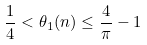<formula> <loc_0><loc_0><loc_500><loc_500>\frac { 1 } { 4 } < \theta _ { 1 } ( n ) \leq \frac { 4 } { \pi } - 1</formula> 